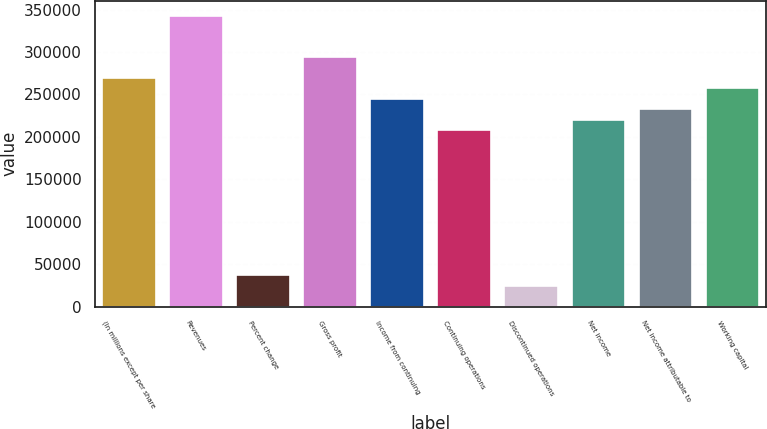Convert chart. <chart><loc_0><loc_0><loc_500><loc_500><bar_chart><fcel>(In millions except per share<fcel>Revenues<fcel>Percent change<fcel>Gross profit<fcel>Income from continuing<fcel>Continuing operations<fcel>Discontinued operations<fcel>Net income<fcel>Net income attributable to<fcel>Working capital<nl><fcel>269396<fcel>342867<fcel>36736.5<fcel>293886<fcel>244905<fcel>208170<fcel>24491.2<fcel>220415<fcel>232660<fcel>257150<nl></chart> 